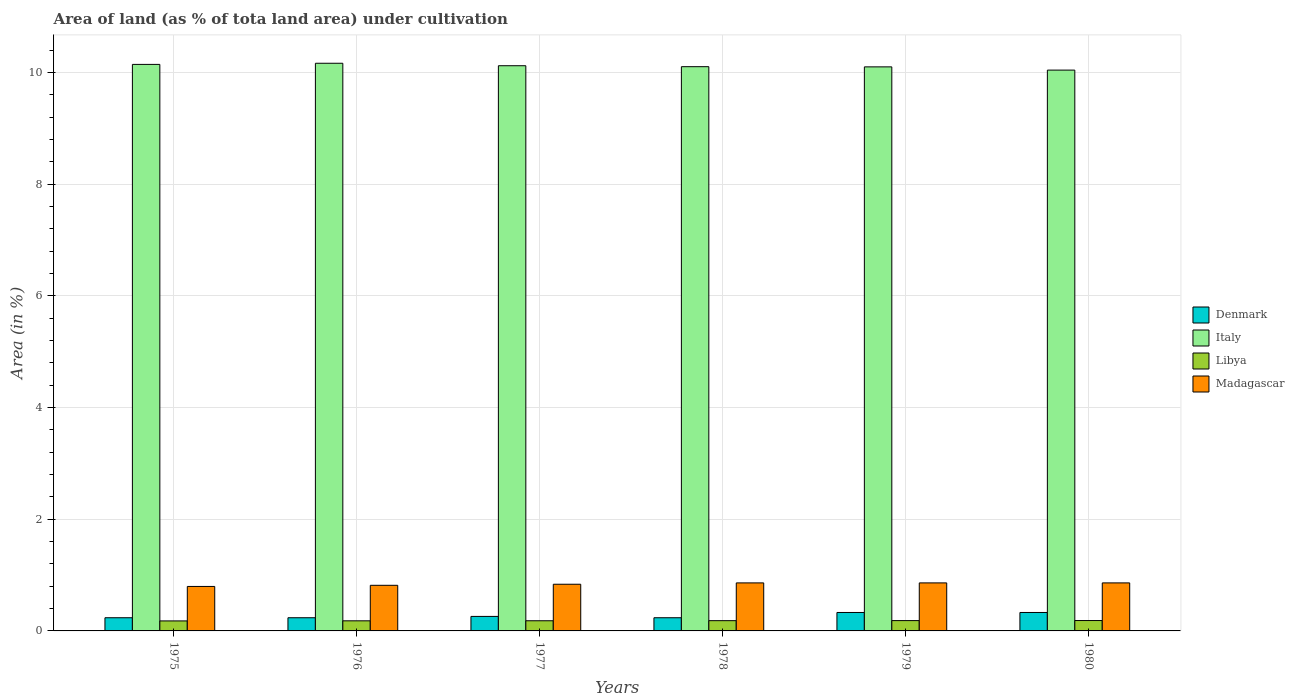How many groups of bars are there?
Your answer should be compact. 6. How many bars are there on the 3rd tick from the right?
Make the answer very short. 4. In how many cases, is the number of bars for a given year not equal to the number of legend labels?
Give a very brief answer. 0. What is the percentage of land under cultivation in Madagascar in 1980?
Provide a succinct answer. 0.86. Across all years, what is the maximum percentage of land under cultivation in Denmark?
Offer a terse response. 0.33. Across all years, what is the minimum percentage of land under cultivation in Madagascar?
Give a very brief answer. 0.8. In which year was the percentage of land under cultivation in Denmark maximum?
Offer a terse response. 1979. In which year was the percentage of land under cultivation in Denmark minimum?
Your answer should be compact. 1975. What is the total percentage of land under cultivation in Libya in the graph?
Your answer should be compact. 1.1. What is the difference between the percentage of land under cultivation in Denmark in 1975 and that in 1978?
Give a very brief answer. 0. What is the difference between the percentage of land under cultivation in Denmark in 1978 and the percentage of land under cultivation in Italy in 1980?
Make the answer very short. -9.8. What is the average percentage of land under cultivation in Italy per year?
Offer a very short reply. 10.11. In the year 1977, what is the difference between the percentage of land under cultivation in Madagascar and percentage of land under cultivation in Italy?
Offer a terse response. -9.28. What is the ratio of the percentage of land under cultivation in Denmark in 1977 to that in 1979?
Offer a terse response. 0.79. What is the difference between the highest and the second highest percentage of land under cultivation in Libya?
Offer a very short reply. 0. What is the difference between the highest and the lowest percentage of land under cultivation in Italy?
Your answer should be compact. 0.12. In how many years, is the percentage of land under cultivation in Denmark greater than the average percentage of land under cultivation in Denmark taken over all years?
Give a very brief answer. 2. Is the sum of the percentage of land under cultivation in Denmark in 1976 and 1979 greater than the maximum percentage of land under cultivation in Italy across all years?
Offer a terse response. No. Is it the case that in every year, the sum of the percentage of land under cultivation in Denmark and percentage of land under cultivation in Italy is greater than the percentage of land under cultivation in Libya?
Make the answer very short. Yes. What is the difference between two consecutive major ticks on the Y-axis?
Provide a succinct answer. 2. Are the values on the major ticks of Y-axis written in scientific E-notation?
Your answer should be compact. No. Does the graph contain grids?
Provide a succinct answer. Yes. How are the legend labels stacked?
Provide a succinct answer. Vertical. What is the title of the graph?
Your answer should be compact. Area of land (as % of tota land area) under cultivation. Does "Bosnia and Herzegovina" appear as one of the legend labels in the graph?
Keep it short and to the point. No. What is the label or title of the X-axis?
Offer a terse response. Years. What is the label or title of the Y-axis?
Your response must be concise. Area (in %). What is the Area (in %) of Denmark in 1975?
Keep it short and to the point. 0.24. What is the Area (in %) of Italy in 1975?
Make the answer very short. 10.14. What is the Area (in %) in Libya in 1975?
Your answer should be very brief. 0.18. What is the Area (in %) of Madagascar in 1975?
Your response must be concise. 0.8. What is the Area (in %) of Denmark in 1976?
Keep it short and to the point. 0.24. What is the Area (in %) of Italy in 1976?
Keep it short and to the point. 10.16. What is the Area (in %) of Libya in 1976?
Offer a terse response. 0.18. What is the Area (in %) of Madagascar in 1976?
Your answer should be compact. 0.82. What is the Area (in %) of Denmark in 1977?
Keep it short and to the point. 0.26. What is the Area (in %) in Italy in 1977?
Provide a succinct answer. 10.12. What is the Area (in %) in Libya in 1977?
Your answer should be compact. 0.18. What is the Area (in %) in Madagascar in 1977?
Provide a succinct answer. 0.84. What is the Area (in %) in Denmark in 1978?
Keep it short and to the point. 0.24. What is the Area (in %) of Italy in 1978?
Your response must be concise. 10.1. What is the Area (in %) in Libya in 1978?
Your answer should be very brief. 0.18. What is the Area (in %) of Madagascar in 1978?
Ensure brevity in your answer.  0.86. What is the Area (in %) in Denmark in 1979?
Your answer should be very brief. 0.33. What is the Area (in %) of Italy in 1979?
Make the answer very short. 10.1. What is the Area (in %) in Libya in 1979?
Your response must be concise. 0.18. What is the Area (in %) of Madagascar in 1979?
Provide a short and direct response. 0.86. What is the Area (in %) of Denmark in 1980?
Your answer should be very brief. 0.33. What is the Area (in %) in Italy in 1980?
Provide a succinct answer. 10.04. What is the Area (in %) of Libya in 1980?
Offer a very short reply. 0.19. What is the Area (in %) in Madagascar in 1980?
Provide a short and direct response. 0.86. Across all years, what is the maximum Area (in %) of Denmark?
Make the answer very short. 0.33. Across all years, what is the maximum Area (in %) of Italy?
Provide a succinct answer. 10.16. Across all years, what is the maximum Area (in %) of Libya?
Your answer should be compact. 0.19. Across all years, what is the maximum Area (in %) in Madagascar?
Keep it short and to the point. 0.86. Across all years, what is the minimum Area (in %) of Denmark?
Provide a short and direct response. 0.24. Across all years, what is the minimum Area (in %) in Italy?
Keep it short and to the point. 10.04. Across all years, what is the minimum Area (in %) of Libya?
Ensure brevity in your answer.  0.18. Across all years, what is the minimum Area (in %) in Madagascar?
Provide a short and direct response. 0.8. What is the total Area (in %) of Denmark in the graph?
Give a very brief answer. 1.63. What is the total Area (in %) in Italy in the graph?
Offer a very short reply. 60.66. What is the total Area (in %) in Libya in the graph?
Keep it short and to the point. 1.1. What is the total Area (in %) of Madagascar in the graph?
Provide a short and direct response. 5.03. What is the difference between the Area (in %) in Italy in 1975 and that in 1976?
Your answer should be compact. -0.02. What is the difference between the Area (in %) in Libya in 1975 and that in 1976?
Provide a succinct answer. -0. What is the difference between the Area (in %) of Madagascar in 1975 and that in 1976?
Your answer should be compact. -0.02. What is the difference between the Area (in %) of Denmark in 1975 and that in 1977?
Your answer should be very brief. -0.02. What is the difference between the Area (in %) in Italy in 1975 and that in 1977?
Keep it short and to the point. 0.02. What is the difference between the Area (in %) in Libya in 1975 and that in 1977?
Make the answer very short. -0. What is the difference between the Area (in %) in Madagascar in 1975 and that in 1977?
Ensure brevity in your answer.  -0.04. What is the difference between the Area (in %) in Denmark in 1975 and that in 1978?
Offer a terse response. 0. What is the difference between the Area (in %) in Italy in 1975 and that in 1978?
Keep it short and to the point. 0.04. What is the difference between the Area (in %) in Libya in 1975 and that in 1978?
Ensure brevity in your answer.  -0. What is the difference between the Area (in %) of Madagascar in 1975 and that in 1978?
Your response must be concise. -0.06. What is the difference between the Area (in %) of Denmark in 1975 and that in 1979?
Offer a terse response. -0.09. What is the difference between the Area (in %) of Italy in 1975 and that in 1979?
Offer a terse response. 0.04. What is the difference between the Area (in %) in Libya in 1975 and that in 1979?
Offer a very short reply. -0.01. What is the difference between the Area (in %) of Madagascar in 1975 and that in 1979?
Keep it short and to the point. -0.06. What is the difference between the Area (in %) in Denmark in 1975 and that in 1980?
Provide a short and direct response. -0.09. What is the difference between the Area (in %) in Italy in 1975 and that in 1980?
Keep it short and to the point. 0.1. What is the difference between the Area (in %) of Libya in 1975 and that in 1980?
Your answer should be very brief. -0.01. What is the difference between the Area (in %) of Madagascar in 1975 and that in 1980?
Give a very brief answer. -0.06. What is the difference between the Area (in %) in Denmark in 1976 and that in 1977?
Your answer should be very brief. -0.02. What is the difference between the Area (in %) in Italy in 1976 and that in 1977?
Offer a very short reply. 0.04. What is the difference between the Area (in %) of Libya in 1976 and that in 1977?
Give a very brief answer. -0. What is the difference between the Area (in %) in Madagascar in 1976 and that in 1977?
Your answer should be very brief. -0.02. What is the difference between the Area (in %) of Italy in 1976 and that in 1978?
Ensure brevity in your answer.  0.06. What is the difference between the Area (in %) of Libya in 1976 and that in 1978?
Give a very brief answer. -0. What is the difference between the Area (in %) of Madagascar in 1976 and that in 1978?
Make the answer very short. -0.04. What is the difference between the Area (in %) of Denmark in 1976 and that in 1979?
Provide a succinct answer. -0.09. What is the difference between the Area (in %) of Italy in 1976 and that in 1979?
Provide a short and direct response. 0.06. What is the difference between the Area (in %) in Libya in 1976 and that in 1979?
Keep it short and to the point. -0. What is the difference between the Area (in %) of Madagascar in 1976 and that in 1979?
Your answer should be compact. -0.04. What is the difference between the Area (in %) of Denmark in 1976 and that in 1980?
Provide a succinct answer. -0.09. What is the difference between the Area (in %) in Italy in 1976 and that in 1980?
Keep it short and to the point. 0.12. What is the difference between the Area (in %) in Libya in 1976 and that in 1980?
Offer a very short reply. -0.01. What is the difference between the Area (in %) in Madagascar in 1976 and that in 1980?
Offer a very short reply. -0.04. What is the difference between the Area (in %) of Denmark in 1977 and that in 1978?
Offer a terse response. 0.02. What is the difference between the Area (in %) of Italy in 1977 and that in 1978?
Provide a short and direct response. 0.02. What is the difference between the Area (in %) of Libya in 1977 and that in 1978?
Keep it short and to the point. -0. What is the difference between the Area (in %) of Madagascar in 1977 and that in 1978?
Ensure brevity in your answer.  -0.02. What is the difference between the Area (in %) of Denmark in 1977 and that in 1979?
Your response must be concise. -0.07. What is the difference between the Area (in %) of Italy in 1977 and that in 1979?
Your answer should be very brief. 0.02. What is the difference between the Area (in %) of Libya in 1977 and that in 1979?
Offer a very short reply. -0. What is the difference between the Area (in %) in Madagascar in 1977 and that in 1979?
Provide a succinct answer. -0.02. What is the difference between the Area (in %) in Denmark in 1977 and that in 1980?
Keep it short and to the point. -0.07. What is the difference between the Area (in %) in Italy in 1977 and that in 1980?
Your answer should be compact. 0.08. What is the difference between the Area (in %) in Libya in 1977 and that in 1980?
Your response must be concise. -0. What is the difference between the Area (in %) in Madagascar in 1977 and that in 1980?
Make the answer very short. -0.02. What is the difference between the Area (in %) in Denmark in 1978 and that in 1979?
Provide a succinct answer. -0.09. What is the difference between the Area (in %) in Italy in 1978 and that in 1979?
Ensure brevity in your answer.  0. What is the difference between the Area (in %) of Libya in 1978 and that in 1979?
Provide a succinct answer. -0. What is the difference between the Area (in %) in Madagascar in 1978 and that in 1979?
Give a very brief answer. 0. What is the difference between the Area (in %) of Denmark in 1978 and that in 1980?
Offer a very short reply. -0.09. What is the difference between the Area (in %) of Italy in 1978 and that in 1980?
Your answer should be compact. 0.06. What is the difference between the Area (in %) in Libya in 1978 and that in 1980?
Make the answer very short. -0. What is the difference between the Area (in %) in Denmark in 1979 and that in 1980?
Make the answer very short. 0. What is the difference between the Area (in %) in Italy in 1979 and that in 1980?
Your answer should be very brief. 0.06. What is the difference between the Area (in %) of Libya in 1979 and that in 1980?
Keep it short and to the point. -0. What is the difference between the Area (in %) of Denmark in 1975 and the Area (in %) of Italy in 1976?
Your answer should be compact. -9.93. What is the difference between the Area (in %) in Denmark in 1975 and the Area (in %) in Libya in 1976?
Your response must be concise. 0.06. What is the difference between the Area (in %) of Denmark in 1975 and the Area (in %) of Madagascar in 1976?
Provide a succinct answer. -0.58. What is the difference between the Area (in %) in Italy in 1975 and the Area (in %) in Libya in 1976?
Offer a terse response. 9.96. What is the difference between the Area (in %) of Italy in 1975 and the Area (in %) of Madagascar in 1976?
Offer a very short reply. 9.33. What is the difference between the Area (in %) of Libya in 1975 and the Area (in %) of Madagascar in 1976?
Your response must be concise. -0.64. What is the difference between the Area (in %) in Denmark in 1975 and the Area (in %) in Italy in 1977?
Make the answer very short. -9.88. What is the difference between the Area (in %) of Denmark in 1975 and the Area (in %) of Libya in 1977?
Give a very brief answer. 0.05. What is the difference between the Area (in %) in Denmark in 1975 and the Area (in %) in Madagascar in 1977?
Your answer should be compact. -0.6. What is the difference between the Area (in %) in Italy in 1975 and the Area (in %) in Libya in 1977?
Offer a terse response. 9.96. What is the difference between the Area (in %) in Italy in 1975 and the Area (in %) in Madagascar in 1977?
Provide a succinct answer. 9.31. What is the difference between the Area (in %) of Libya in 1975 and the Area (in %) of Madagascar in 1977?
Your response must be concise. -0.66. What is the difference between the Area (in %) in Denmark in 1975 and the Area (in %) in Italy in 1978?
Give a very brief answer. -9.87. What is the difference between the Area (in %) in Denmark in 1975 and the Area (in %) in Libya in 1978?
Your response must be concise. 0.05. What is the difference between the Area (in %) of Denmark in 1975 and the Area (in %) of Madagascar in 1978?
Offer a very short reply. -0.62. What is the difference between the Area (in %) in Italy in 1975 and the Area (in %) in Libya in 1978?
Ensure brevity in your answer.  9.96. What is the difference between the Area (in %) in Italy in 1975 and the Area (in %) in Madagascar in 1978?
Provide a succinct answer. 9.28. What is the difference between the Area (in %) of Libya in 1975 and the Area (in %) of Madagascar in 1978?
Provide a short and direct response. -0.68. What is the difference between the Area (in %) in Denmark in 1975 and the Area (in %) in Italy in 1979?
Provide a short and direct response. -9.86. What is the difference between the Area (in %) of Denmark in 1975 and the Area (in %) of Libya in 1979?
Your answer should be compact. 0.05. What is the difference between the Area (in %) of Denmark in 1975 and the Area (in %) of Madagascar in 1979?
Provide a succinct answer. -0.62. What is the difference between the Area (in %) in Italy in 1975 and the Area (in %) in Libya in 1979?
Provide a short and direct response. 9.96. What is the difference between the Area (in %) of Italy in 1975 and the Area (in %) of Madagascar in 1979?
Offer a very short reply. 9.28. What is the difference between the Area (in %) in Libya in 1975 and the Area (in %) in Madagascar in 1979?
Your answer should be very brief. -0.68. What is the difference between the Area (in %) in Denmark in 1975 and the Area (in %) in Italy in 1980?
Provide a succinct answer. -9.8. What is the difference between the Area (in %) of Denmark in 1975 and the Area (in %) of Libya in 1980?
Your answer should be compact. 0.05. What is the difference between the Area (in %) of Denmark in 1975 and the Area (in %) of Madagascar in 1980?
Give a very brief answer. -0.62. What is the difference between the Area (in %) of Italy in 1975 and the Area (in %) of Libya in 1980?
Your answer should be very brief. 9.96. What is the difference between the Area (in %) of Italy in 1975 and the Area (in %) of Madagascar in 1980?
Provide a short and direct response. 9.28. What is the difference between the Area (in %) in Libya in 1975 and the Area (in %) in Madagascar in 1980?
Provide a short and direct response. -0.68. What is the difference between the Area (in %) in Denmark in 1976 and the Area (in %) in Italy in 1977?
Give a very brief answer. -9.88. What is the difference between the Area (in %) of Denmark in 1976 and the Area (in %) of Libya in 1977?
Offer a terse response. 0.05. What is the difference between the Area (in %) in Denmark in 1976 and the Area (in %) in Madagascar in 1977?
Your answer should be very brief. -0.6. What is the difference between the Area (in %) of Italy in 1976 and the Area (in %) of Libya in 1977?
Ensure brevity in your answer.  9.98. What is the difference between the Area (in %) in Italy in 1976 and the Area (in %) in Madagascar in 1977?
Provide a short and direct response. 9.33. What is the difference between the Area (in %) of Libya in 1976 and the Area (in %) of Madagascar in 1977?
Make the answer very short. -0.66. What is the difference between the Area (in %) of Denmark in 1976 and the Area (in %) of Italy in 1978?
Your answer should be compact. -9.87. What is the difference between the Area (in %) of Denmark in 1976 and the Area (in %) of Libya in 1978?
Make the answer very short. 0.05. What is the difference between the Area (in %) of Denmark in 1976 and the Area (in %) of Madagascar in 1978?
Ensure brevity in your answer.  -0.62. What is the difference between the Area (in %) of Italy in 1976 and the Area (in %) of Libya in 1978?
Your response must be concise. 9.98. What is the difference between the Area (in %) of Italy in 1976 and the Area (in %) of Madagascar in 1978?
Make the answer very short. 9.3. What is the difference between the Area (in %) in Libya in 1976 and the Area (in %) in Madagascar in 1978?
Offer a terse response. -0.68. What is the difference between the Area (in %) in Denmark in 1976 and the Area (in %) in Italy in 1979?
Provide a short and direct response. -9.86. What is the difference between the Area (in %) in Denmark in 1976 and the Area (in %) in Libya in 1979?
Your answer should be very brief. 0.05. What is the difference between the Area (in %) in Denmark in 1976 and the Area (in %) in Madagascar in 1979?
Your answer should be very brief. -0.62. What is the difference between the Area (in %) of Italy in 1976 and the Area (in %) of Libya in 1979?
Make the answer very short. 9.98. What is the difference between the Area (in %) of Italy in 1976 and the Area (in %) of Madagascar in 1979?
Keep it short and to the point. 9.3. What is the difference between the Area (in %) in Libya in 1976 and the Area (in %) in Madagascar in 1979?
Your response must be concise. -0.68. What is the difference between the Area (in %) of Denmark in 1976 and the Area (in %) of Italy in 1980?
Your answer should be very brief. -9.8. What is the difference between the Area (in %) of Denmark in 1976 and the Area (in %) of Libya in 1980?
Provide a short and direct response. 0.05. What is the difference between the Area (in %) in Denmark in 1976 and the Area (in %) in Madagascar in 1980?
Provide a short and direct response. -0.62. What is the difference between the Area (in %) in Italy in 1976 and the Area (in %) in Libya in 1980?
Provide a succinct answer. 9.98. What is the difference between the Area (in %) in Italy in 1976 and the Area (in %) in Madagascar in 1980?
Provide a short and direct response. 9.3. What is the difference between the Area (in %) in Libya in 1976 and the Area (in %) in Madagascar in 1980?
Ensure brevity in your answer.  -0.68. What is the difference between the Area (in %) of Denmark in 1977 and the Area (in %) of Italy in 1978?
Provide a succinct answer. -9.84. What is the difference between the Area (in %) in Denmark in 1977 and the Area (in %) in Libya in 1978?
Ensure brevity in your answer.  0.08. What is the difference between the Area (in %) of Denmark in 1977 and the Area (in %) of Madagascar in 1978?
Ensure brevity in your answer.  -0.6. What is the difference between the Area (in %) in Italy in 1977 and the Area (in %) in Libya in 1978?
Your answer should be very brief. 9.94. What is the difference between the Area (in %) in Italy in 1977 and the Area (in %) in Madagascar in 1978?
Make the answer very short. 9.26. What is the difference between the Area (in %) of Libya in 1977 and the Area (in %) of Madagascar in 1978?
Ensure brevity in your answer.  -0.68. What is the difference between the Area (in %) of Denmark in 1977 and the Area (in %) of Italy in 1979?
Provide a succinct answer. -9.84. What is the difference between the Area (in %) in Denmark in 1977 and the Area (in %) in Libya in 1979?
Keep it short and to the point. 0.07. What is the difference between the Area (in %) in Denmark in 1977 and the Area (in %) in Madagascar in 1979?
Offer a very short reply. -0.6. What is the difference between the Area (in %) of Italy in 1977 and the Area (in %) of Libya in 1979?
Offer a very short reply. 9.93. What is the difference between the Area (in %) in Italy in 1977 and the Area (in %) in Madagascar in 1979?
Offer a very short reply. 9.26. What is the difference between the Area (in %) of Libya in 1977 and the Area (in %) of Madagascar in 1979?
Provide a succinct answer. -0.68. What is the difference between the Area (in %) in Denmark in 1977 and the Area (in %) in Italy in 1980?
Make the answer very short. -9.78. What is the difference between the Area (in %) of Denmark in 1977 and the Area (in %) of Libya in 1980?
Offer a very short reply. 0.07. What is the difference between the Area (in %) in Denmark in 1977 and the Area (in %) in Madagascar in 1980?
Your response must be concise. -0.6. What is the difference between the Area (in %) of Italy in 1977 and the Area (in %) of Libya in 1980?
Offer a terse response. 9.93. What is the difference between the Area (in %) in Italy in 1977 and the Area (in %) in Madagascar in 1980?
Ensure brevity in your answer.  9.26. What is the difference between the Area (in %) of Libya in 1977 and the Area (in %) of Madagascar in 1980?
Your answer should be very brief. -0.68. What is the difference between the Area (in %) in Denmark in 1978 and the Area (in %) in Italy in 1979?
Keep it short and to the point. -9.86. What is the difference between the Area (in %) of Denmark in 1978 and the Area (in %) of Libya in 1979?
Offer a terse response. 0.05. What is the difference between the Area (in %) in Denmark in 1978 and the Area (in %) in Madagascar in 1979?
Ensure brevity in your answer.  -0.62. What is the difference between the Area (in %) of Italy in 1978 and the Area (in %) of Libya in 1979?
Your response must be concise. 9.92. What is the difference between the Area (in %) of Italy in 1978 and the Area (in %) of Madagascar in 1979?
Your response must be concise. 9.24. What is the difference between the Area (in %) of Libya in 1978 and the Area (in %) of Madagascar in 1979?
Your answer should be compact. -0.68. What is the difference between the Area (in %) of Denmark in 1978 and the Area (in %) of Italy in 1980?
Your response must be concise. -9.8. What is the difference between the Area (in %) of Denmark in 1978 and the Area (in %) of Libya in 1980?
Make the answer very short. 0.05. What is the difference between the Area (in %) of Denmark in 1978 and the Area (in %) of Madagascar in 1980?
Ensure brevity in your answer.  -0.62. What is the difference between the Area (in %) of Italy in 1978 and the Area (in %) of Libya in 1980?
Your answer should be very brief. 9.92. What is the difference between the Area (in %) in Italy in 1978 and the Area (in %) in Madagascar in 1980?
Give a very brief answer. 9.24. What is the difference between the Area (in %) in Libya in 1978 and the Area (in %) in Madagascar in 1980?
Provide a succinct answer. -0.68. What is the difference between the Area (in %) in Denmark in 1979 and the Area (in %) in Italy in 1980?
Give a very brief answer. -9.71. What is the difference between the Area (in %) in Denmark in 1979 and the Area (in %) in Libya in 1980?
Provide a short and direct response. 0.14. What is the difference between the Area (in %) in Denmark in 1979 and the Area (in %) in Madagascar in 1980?
Keep it short and to the point. -0.53. What is the difference between the Area (in %) in Italy in 1979 and the Area (in %) in Libya in 1980?
Provide a succinct answer. 9.91. What is the difference between the Area (in %) in Italy in 1979 and the Area (in %) in Madagascar in 1980?
Offer a terse response. 9.24. What is the difference between the Area (in %) of Libya in 1979 and the Area (in %) of Madagascar in 1980?
Offer a terse response. -0.68. What is the average Area (in %) of Denmark per year?
Your answer should be compact. 0.27. What is the average Area (in %) in Italy per year?
Keep it short and to the point. 10.11. What is the average Area (in %) in Libya per year?
Give a very brief answer. 0.18. What is the average Area (in %) in Madagascar per year?
Make the answer very short. 0.84. In the year 1975, what is the difference between the Area (in %) in Denmark and Area (in %) in Italy?
Your answer should be compact. -9.91. In the year 1975, what is the difference between the Area (in %) of Denmark and Area (in %) of Libya?
Provide a short and direct response. 0.06. In the year 1975, what is the difference between the Area (in %) of Denmark and Area (in %) of Madagascar?
Give a very brief answer. -0.56. In the year 1975, what is the difference between the Area (in %) of Italy and Area (in %) of Libya?
Your answer should be very brief. 9.96. In the year 1975, what is the difference between the Area (in %) in Italy and Area (in %) in Madagascar?
Your answer should be compact. 9.35. In the year 1975, what is the difference between the Area (in %) in Libya and Area (in %) in Madagascar?
Provide a short and direct response. -0.62. In the year 1976, what is the difference between the Area (in %) in Denmark and Area (in %) in Italy?
Give a very brief answer. -9.93. In the year 1976, what is the difference between the Area (in %) in Denmark and Area (in %) in Libya?
Make the answer very short. 0.06. In the year 1976, what is the difference between the Area (in %) of Denmark and Area (in %) of Madagascar?
Your answer should be compact. -0.58. In the year 1976, what is the difference between the Area (in %) of Italy and Area (in %) of Libya?
Your response must be concise. 9.98. In the year 1976, what is the difference between the Area (in %) in Italy and Area (in %) in Madagascar?
Provide a succinct answer. 9.35. In the year 1976, what is the difference between the Area (in %) in Libya and Area (in %) in Madagascar?
Make the answer very short. -0.64. In the year 1977, what is the difference between the Area (in %) of Denmark and Area (in %) of Italy?
Make the answer very short. -9.86. In the year 1977, what is the difference between the Area (in %) of Denmark and Area (in %) of Libya?
Offer a terse response. 0.08. In the year 1977, what is the difference between the Area (in %) of Denmark and Area (in %) of Madagascar?
Your answer should be compact. -0.58. In the year 1977, what is the difference between the Area (in %) of Italy and Area (in %) of Libya?
Provide a succinct answer. 9.94. In the year 1977, what is the difference between the Area (in %) in Italy and Area (in %) in Madagascar?
Give a very brief answer. 9.28. In the year 1977, what is the difference between the Area (in %) in Libya and Area (in %) in Madagascar?
Offer a very short reply. -0.65. In the year 1978, what is the difference between the Area (in %) in Denmark and Area (in %) in Italy?
Offer a very short reply. -9.87. In the year 1978, what is the difference between the Area (in %) of Denmark and Area (in %) of Libya?
Keep it short and to the point. 0.05. In the year 1978, what is the difference between the Area (in %) in Denmark and Area (in %) in Madagascar?
Make the answer very short. -0.62. In the year 1978, what is the difference between the Area (in %) in Italy and Area (in %) in Libya?
Your answer should be very brief. 9.92. In the year 1978, what is the difference between the Area (in %) in Italy and Area (in %) in Madagascar?
Ensure brevity in your answer.  9.24. In the year 1978, what is the difference between the Area (in %) of Libya and Area (in %) of Madagascar?
Your answer should be compact. -0.68. In the year 1979, what is the difference between the Area (in %) of Denmark and Area (in %) of Italy?
Your answer should be compact. -9.77. In the year 1979, what is the difference between the Area (in %) of Denmark and Area (in %) of Libya?
Your answer should be compact. 0.15. In the year 1979, what is the difference between the Area (in %) in Denmark and Area (in %) in Madagascar?
Your answer should be very brief. -0.53. In the year 1979, what is the difference between the Area (in %) of Italy and Area (in %) of Libya?
Offer a terse response. 9.91. In the year 1979, what is the difference between the Area (in %) in Italy and Area (in %) in Madagascar?
Your answer should be compact. 9.24. In the year 1979, what is the difference between the Area (in %) of Libya and Area (in %) of Madagascar?
Provide a succinct answer. -0.68. In the year 1980, what is the difference between the Area (in %) of Denmark and Area (in %) of Italy?
Offer a terse response. -9.71. In the year 1980, what is the difference between the Area (in %) of Denmark and Area (in %) of Libya?
Offer a terse response. 0.14. In the year 1980, what is the difference between the Area (in %) of Denmark and Area (in %) of Madagascar?
Provide a short and direct response. -0.53. In the year 1980, what is the difference between the Area (in %) of Italy and Area (in %) of Libya?
Your response must be concise. 9.85. In the year 1980, what is the difference between the Area (in %) of Italy and Area (in %) of Madagascar?
Your answer should be compact. 9.18. In the year 1980, what is the difference between the Area (in %) in Libya and Area (in %) in Madagascar?
Give a very brief answer. -0.67. What is the ratio of the Area (in %) in Italy in 1975 to that in 1976?
Offer a terse response. 1. What is the ratio of the Area (in %) in Libya in 1975 to that in 1976?
Keep it short and to the point. 0.99. What is the ratio of the Area (in %) of Madagascar in 1975 to that in 1976?
Provide a succinct answer. 0.97. What is the ratio of the Area (in %) in Denmark in 1975 to that in 1977?
Offer a terse response. 0.91. What is the ratio of the Area (in %) of Libya in 1975 to that in 1977?
Give a very brief answer. 0.98. What is the ratio of the Area (in %) of Madagascar in 1975 to that in 1977?
Provide a short and direct response. 0.95. What is the ratio of the Area (in %) in Denmark in 1975 to that in 1978?
Offer a very short reply. 1. What is the ratio of the Area (in %) in Libya in 1975 to that in 1978?
Provide a short and direct response. 0.98. What is the ratio of the Area (in %) in Madagascar in 1975 to that in 1978?
Make the answer very short. 0.93. What is the ratio of the Area (in %) of Denmark in 1975 to that in 1979?
Offer a terse response. 0.71. What is the ratio of the Area (in %) of Italy in 1975 to that in 1979?
Offer a terse response. 1. What is the ratio of the Area (in %) of Libya in 1975 to that in 1979?
Make the answer very short. 0.97. What is the ratio of the Area (in %) in Madagascar in 1975 to that in 1979?
Offer a terse response. 0.93. What is the ratio of the Area (in %) of Denmark in 1975 to that in 1980?
Your answer should be compact. 0.71. What is the ratio of the Area (in %) of Italy in 1975 to that in 1980?
Keep it short and to the point. 1.01. What is the ratio of the Area (in %) in Libya in 1975 to that in 1980?
Make the answer very short. 0.96. What is the ratio of the Area (in %) of Madagascar in 1975 to that in 1980?
Give a very brief answer. 0.93. What is the ratio of the Area (in %) in Denmark in 1976 to that in 1977?
Make the answer very short. 0.91. What is the ratio of the Area (in %) of Italy in 1976 to that in 1977?
Make the answer very short. 1. What is the ratio of the Area (in %) in Madagascar in 1976 to that in 1977?
Your answer should be very brief. 0.98. What is the ratio of the Area (in %) in Denmark in 1976 to that in 1978?
Ensure brevity in your answer.  1. What is the ratio of the Area (in %) of Libya in 1976 to that in 1978?
Keep it short and to the point. 0.98. What is the ratio of the Area (in %) in Denmark in 1976 to that in 1979?
Your response must be concise. 0.71. What is the ratio of the Area (in %) of Italy in 1976 to that in 1979?
Ensure brevity in your answer.  1.01. What is the ratio of the Area (in %) of Libya in 1976 to that in 1979?
Your response must be concise. 0.98. What is the ratio of the Area (in %) of Madagascar in 1976 to that in 1979?
Provide a succinct answer. 0.95. What is the ratio of the Area (in %) of Denmark in 1976 to that in 1980?
Offer a terse response. 0.71. What is the ratio of the Area (in %) of Italy in 1976 to that in 1980?
Your response must be concise. 1.01. What is the ratio of the Area (in %) in Libya in 1976 to that in 1980?
Your answer should be compact. 0.97. What is the ratio of the Area (in %) of Libya in 1977 to that in 1978?
Your answer should be very brief. 0.99. What is the ratio of the Area (in %) in Madagascar in 1977 to that in 1978?
Offer a very short reply. 0.97. What is the ratio of the Area (in %) in Denmark in 1977 to that in 1979?
Offer a terse response. 0.79. What is the ratio of the Area (in %) of Libya in 1977 to that in 1979?
Make the answer very short. 0.98. What is the ratio of the Area (in %) of Madagascar in 1977 to that in 1979?
Keep it short and to the point. 0.97. What is the ratio of the Area (in %) of Denmark in 1977 to that in 1980?
Ensure brevity in your answer.  0.79. What is the ratio of the Area (in %) of Libya in 1977 to that in 1980?
Provide a succinct answer. 0.98. What is the ratio of the Area (in %) in Denmark in 1978 to that in 1979?
Your response must be concise. 0.71. What is the ratio of the Area (in %) of Italy in 1978 to that in 1979?
Ensure brevity in your answer.  1. What is the ratio of the Area (in %) of Madagascar in 1978 to that in 1979?
Make the answer very short. 1. What is the ratio of the Area (in %) in Denmark in 1978 to that in 1980?
Offer a very short reply. 0.71. What is the ratio of the Area (in %) in Madagascar in 1978 to that in 1980?
Ensure brevity in your answer.  1. What is the ratio of the Area (in %) of Libya in 1979 to that in 1980?
Your answer should be compact. 0.99. What is the difference between the highest and the second highest Area (in %) of Denmark?
Provide a short and direct response. 0. What is the difference between the highest and the second highest Area (in %) of Italy?
Provide a short and direct response. 0.02. What is the difference between the highest and the second highest Area (in %) of Libya?
Keep it short and to the point. 0. What is the difference between the highest and the lowest Area (in %) of Denmark?
Your response must be concise. 0.09. What is the difference between the highest and the lowest Area (in %) of Italy?
Give a very brief answer. 0.12. What is the difference between the highest and the lowest Area (in %) in Libya?
Your answer should be very brief. 0.01. What is the difference between the highest and the lowest Area (in %) in Madagascar?
Give a very brief answer. 0.06. 